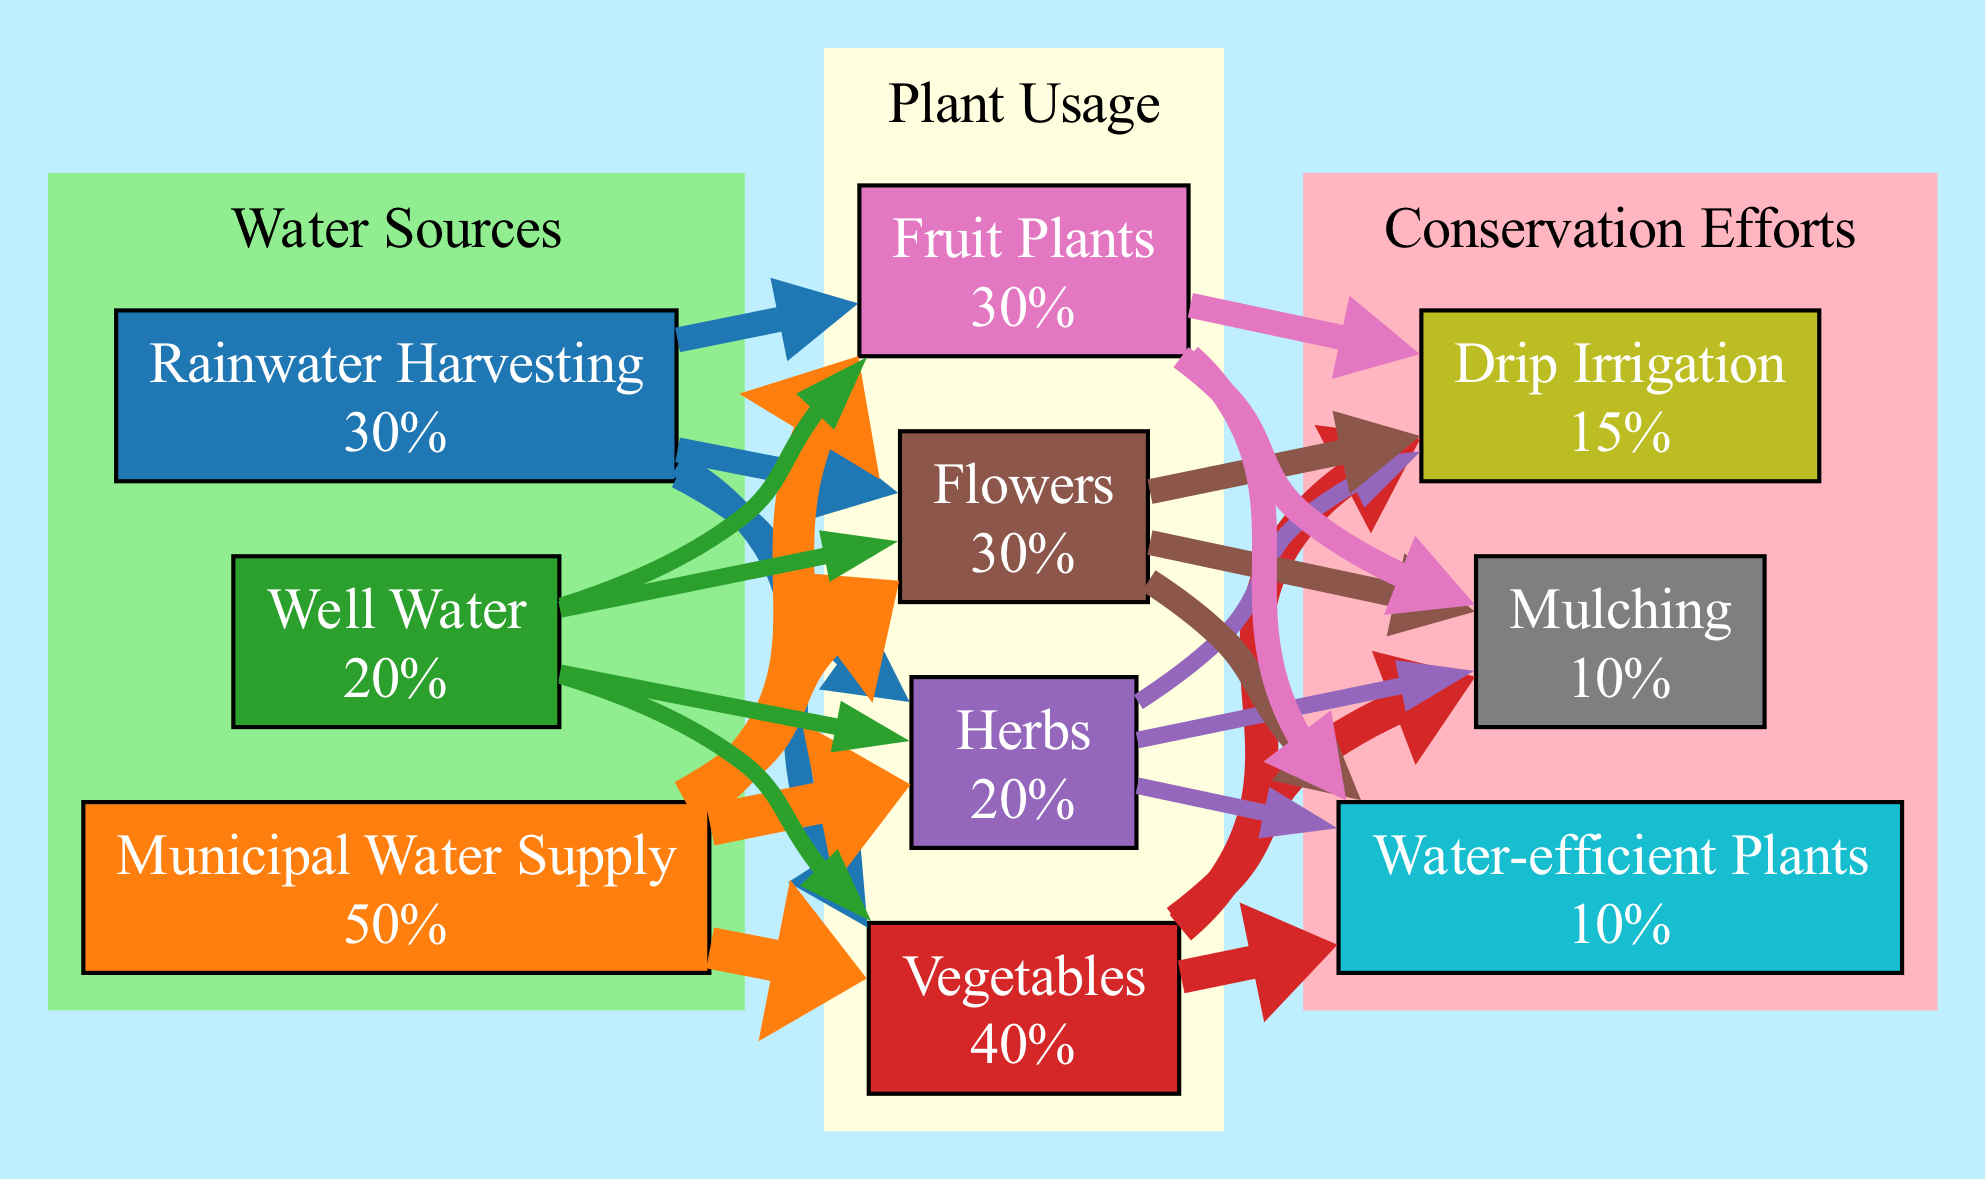What are the total sources of water? The total sources of water are the sum of all the percentages from the sources of water in the diagram: Rainwater Harvesting (30) + Municipal Water Supply (50) + Well Water (20) = 100%.
Answer: 100% How much water do vegetables use? The usage for vegetables is directly listed in the diagram under the Plant Usage cluster, which is 40%.
Answer: 40% What conservation effort has the highest percentage? Among the conservation efforts, Mulching (10%), Drip Irrigation (15%), and Water-efficient Plants (10%) are listed. Drip Irrigation has the highest percentage at 15%.
Answer: Drip Irrigation What percentage of total water comes from the Municipal Water Supply? The Municipal Water Supply contributes 50% of the total sources of water, which can be directly seen in the diagram.
Answer: 50% How does the usage of flowers compare to fruit plants? The usage for flowers is 30%, and for fruit plants, it is also 30%. Since both values are the same, they can be considered equal in terms of water usage.
Answer: Equal What percentage of water used by plants is attributed to conservation efforts? To find this, we can see that the total water used by all plants is 40% (vegetables) + 20% (herbs) + 30% (flowers) + 30% (fruit plants) = 120%. The total reduction from conservation efforts is 10% (Mulching) + 15% (Drip Irrigation) + 10% (Water-efficient Plants) = 35%. Thus, the percentage attributed to conservation efforts is 35% out of a total plant usage of 120%, which is about 29.17%.
Answer: 29.17% Which water source contributes least to total water usage? On examining the sources of water, Well Water, contributing 20%, is the least of the three listed: Rainwater Harvesting (30%) and Municipal Water Supply (50%).
Answer: Well Water How does water usage vary among different types of plants? Water usage varies significantly among plants: Vegetables (40%), Herbs (20%), Flowers (30%), and Fruit Plants (30%). Each plant type has a distinct percentage indicating its specific water usage.
Answer: Varies by type What is the total percentage of conservation efforts? The total percentage of conservation efforts is calculated by summing the individual items: Mulching (10%) + Drip Irrigation (15%) + Water-efficient Plants (10%) = 35%.
Answer: 35% 